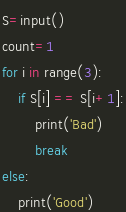Convert code to text. <code><loc_0><loc_0><loc_500><loc_500><_Python_>S=input()
count=1
for i in range(3):
    if S[i] == S[i+1]:
        print('Bad')
        break
else:
    print('Good')
</code> 